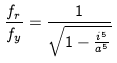Convert formula to latex. <formula><loc_0><loc_0><loc_500><loc_500>\frac { f _ { r } } { f _ { y } } = \frac { 1 } { \sqrt { 1 - \frac { i ^ { 5 } } { a ^ { 5 } } } }</formula> 